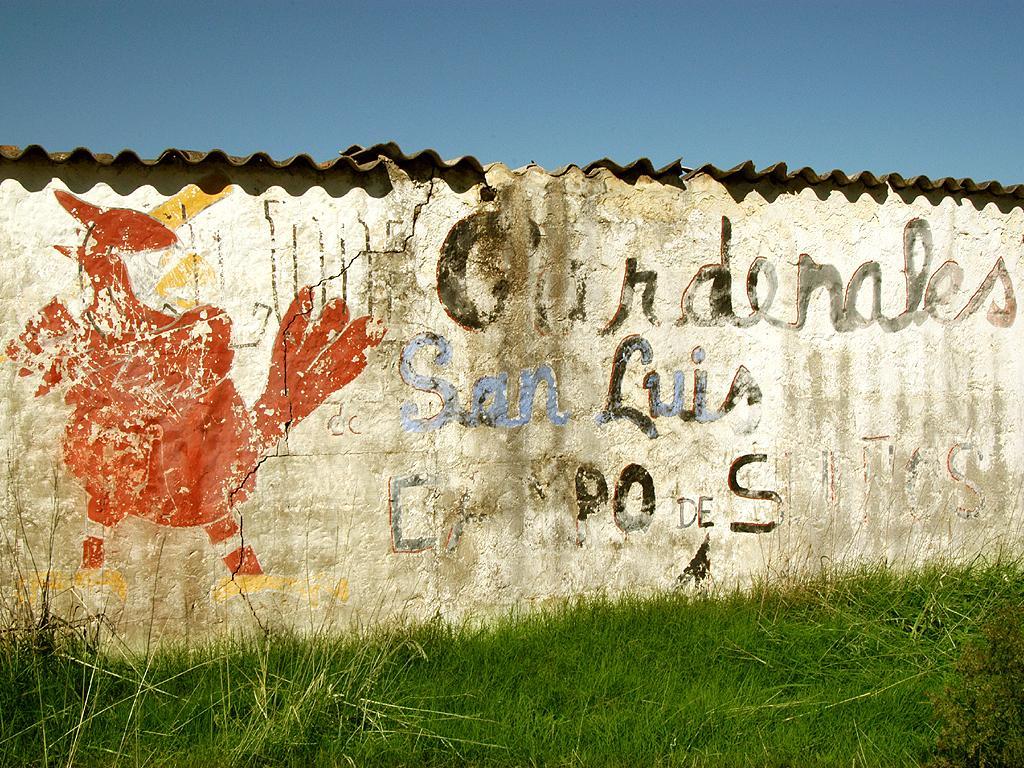Please provide a concise description of this image. This picture is clicked outside. In the foreground we can see the green grass. In the center we can see the house and we can see the text and the drawing of an object on the wall of the house. In the background we can see the sky. 